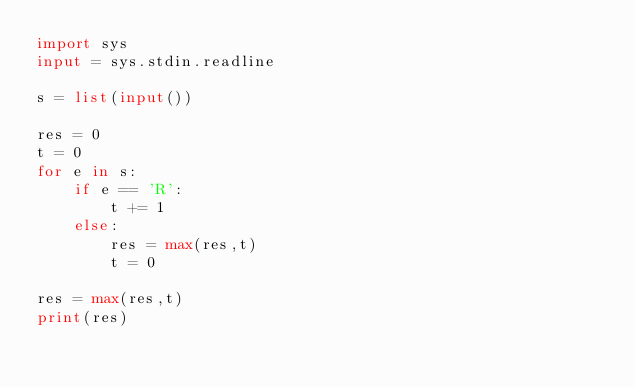<code> <loc_0><loc_0><loc_500><loc_500><_Python_>import sys
input = sys.stdin.readline

s = list(input())

res = 0
t = 0
for e in s:
    if e == 'R':
        t += 1
    else:
        res = max(res,t)
        t = 0

res = max(res,t)
print(res)</code> 